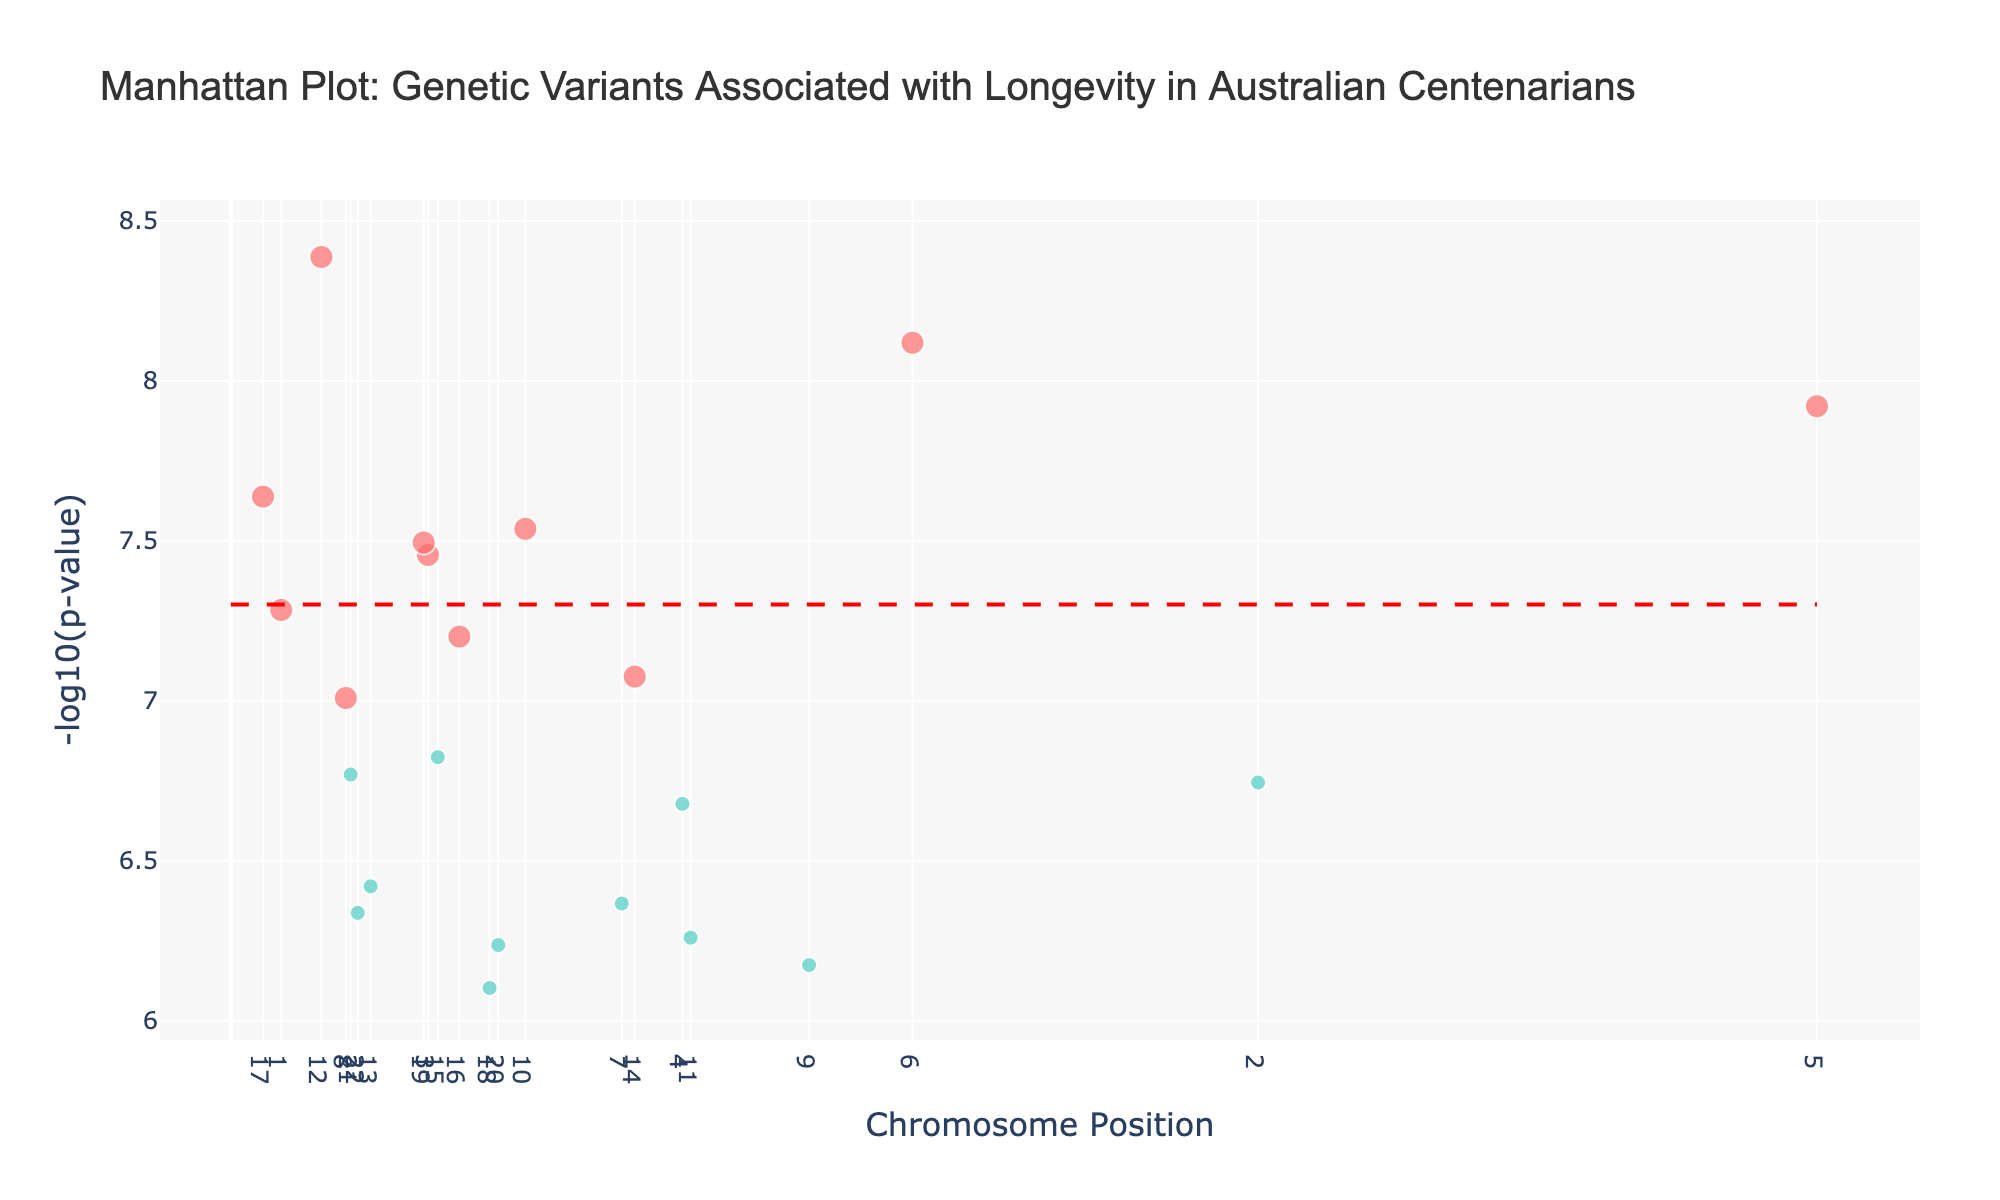Which gene has the lowest p-value? By looking at the figure, identify the gene with the highest y-value on the plot. Since -log10(p-value) is represented on the y-axis, the highest point corresponds to the lowest p-value.
Answer: APOE What is the significance threshold indicated by the horizontal line? The horizontal line often represents a commonly used significance threshold, which in this plot corresponds to -log10(5e-8). Check where the line is located on the y-axis.
Answer: -log10(5e-8) How many genes have a significant association with longevity (p-value < 5e-8)? Count the number of data points that are above the horizontal significance threshold line in the plot.
Answer: 10 Which chromosome has the most significant gene variants? Compare the number of significant points above the threshold horizontally across different chromosomes.
Answer: Chromosome 6 Are there any chromosomes that don't have any significant variants? Check each chromosome's data points. If none of them are above the significance threshold line, then they have no significant variants.
Answer: Yes, Chromosomes 2, 4, 7, 9, 11, 13, 15, 18, 20, 21, and 22 What is the position of the significant variant on chromosome 16? Find the significant point (above the threshold line) on chromosome 16 along the x-axis and note its position on the plot.
Answer: 53804 Which chromosomal position has the highest -log10(p-value) for the gene MTHFR? Locate the chromosomal position labeled for MTHFR on the x-axis, and check the corresponding y-value for -log10(p-value).
Answer: 11870 How many genes have been annotated in this plot? Count the number of unique data points or gene labels present on the plot.
Answer: 22 What is the gene located at chromosome 10 with a significant association? Identify the point in chromosome 10 that is above the significance threshold and check the gene label associated with it.
Answer: SIRT1 